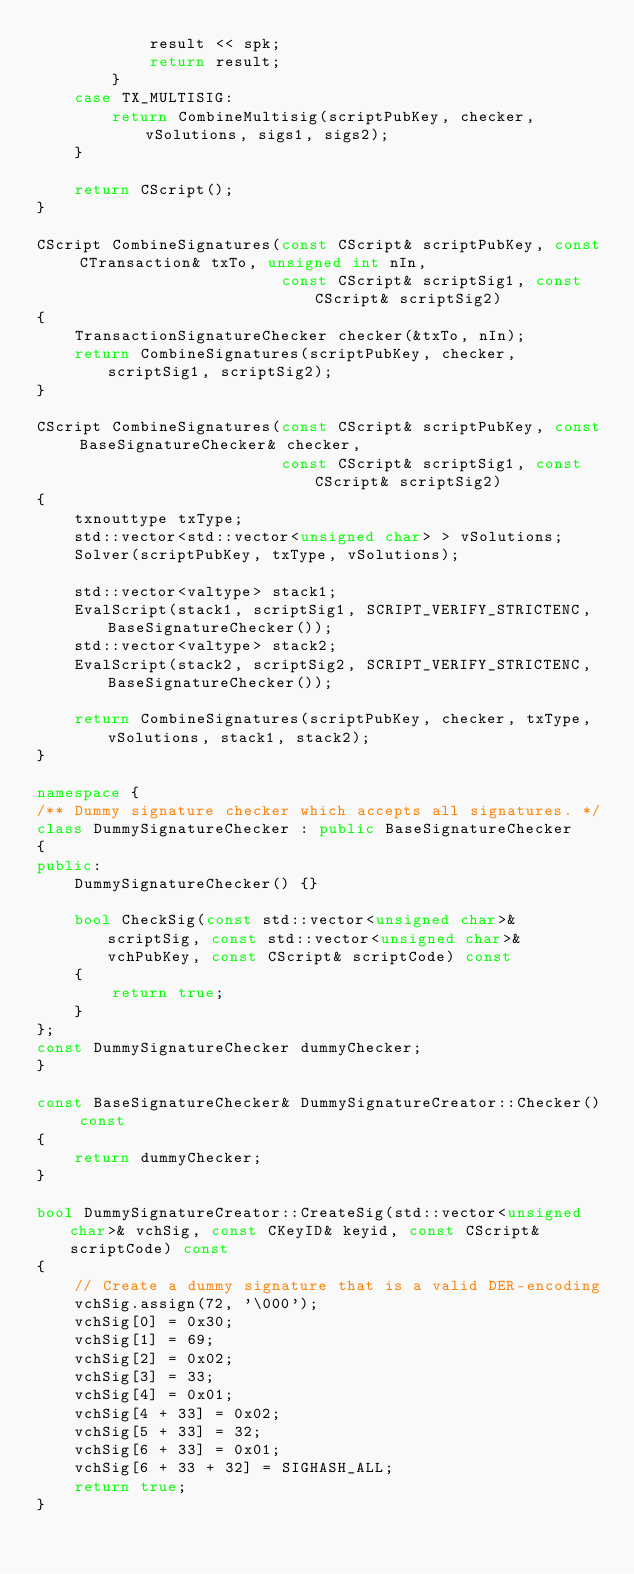Convert code to text. <code><loc_0><loc_0><loc_500><loc_500><_C++_>            result << spk;
            return result;
        }
    case TX_MULTISIG:
        return CombineMultisig(scriptPubKey, checker, vSolutions, sigs1, sigs2);
    }

    return CScript();
}

CScript CombineSignatures(const CScript& scriptPubKey, const CTransaction& txTo, unsigned int nIn,
                          const CScript& scriptSig1, const CScript& scriptSig2)
{
    TransactionSignatureChecker checker(&txTo, nIn);
    return CombineSignatures(scriptPubKey, checker, scriptSig1, scriptSig2);
}

CScript CombineSignatures(const CScript& scriptPubKey, const BaseSignatureChecker& checker,
                          const CScript& scriptSig1, const CScript& scriptSig2)
{
    txnouttype txType;
    std::vector<std::vector<unsigned char> > vSolutions;
    Solver(scriptPubKey, txType, vSolutions);

    std::vector<valtype> stack1;
    EvalScript(stack1, scriptSig1, SCRIPT_VERIFY_STRICTENC, BaseSignatureChecker());
    std::vector<valtype> stack2;
    EvalScript(stack2, scriptSig2, SCRIPT_VERIFY_STRICTENC, BaseSignatureChecker());

    return CombineSignatures(scriptPubKey, checker, txType, vSolutions, stack1, stack2);
}

namespace {
/** Dummy signature checker which accepts all signatures. */
class DummySignatureChecker : public BaseSignatureChecker
{
public:
    DummySignatureChecker() {}

    bool CheckSig(const std::vector<unsigned char>& scriptSig, const std::vector<unsigned char>& vchPubKey, const CScript& scriptCode) const
    {
        return true;
    }
};
const DummySignatureChecker dummyChecker;
}

const BaseSignatureChecker& DummySignatureCreator::Checker() const
{
    return dummyChecker;
}

bool DummySignatureCreator::CreateSig(std::vector<unsigned char>& vchSig, const CKeyID& keyid, const CScript& scriptCode) const
{
    // Create a dummy signature that is a valid DER-encoding
    vchSig.assign(72, '\000');
    vchSig[0] = 0x30;
    vchSig[1] = 69;
    vchSig[2] = 0x02;
    vchSig[3] = 33;
    vchSig[4] = 0x01;
    vchSig[4 + 33] = 0x02;
    vchSig[5 + 33] = 32;
    vchSig[6 + 33] = 0x01;
    vchSig[6 + 33 + 32] = SIGHASH_ALL;
    return true;
}
</code> 